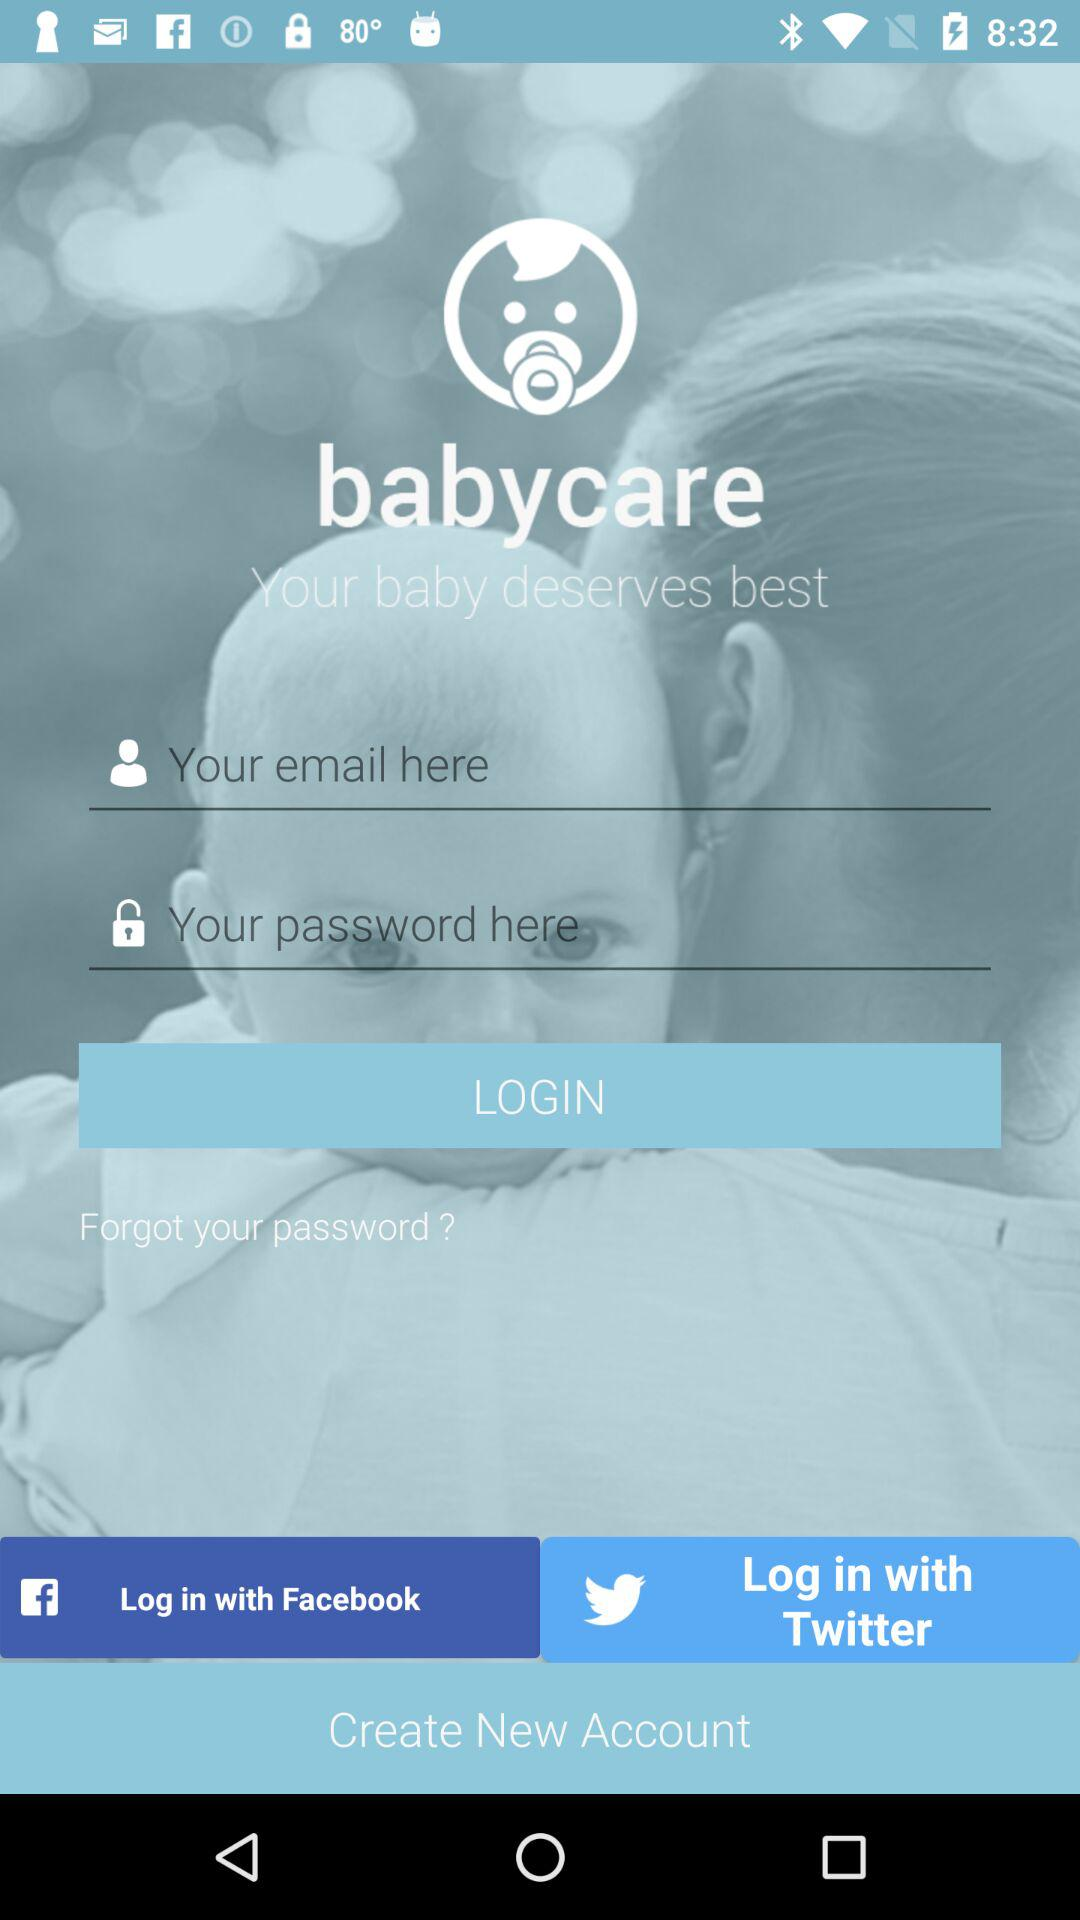What is the application name? The application name is "babycare". 